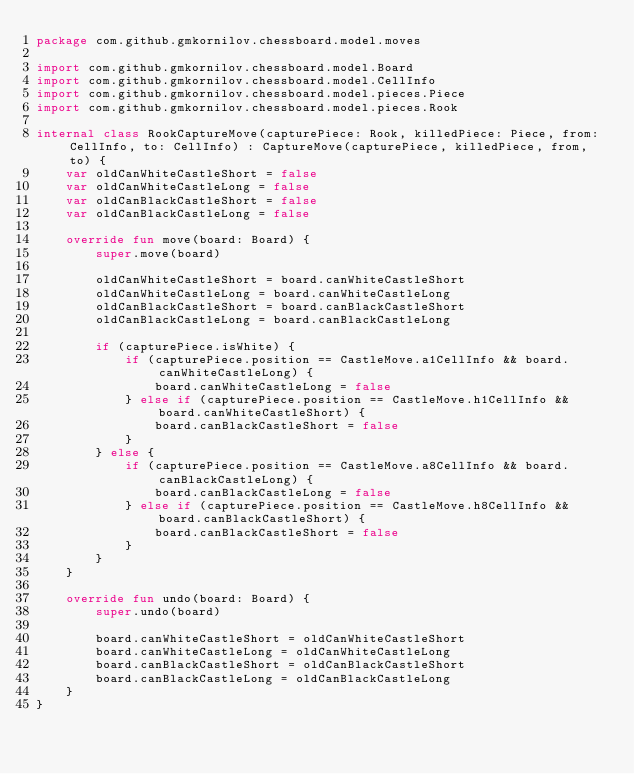Convert code to text. <code><loc_0><loc_0><loc_500><loc_500><_Kotlin_>package com.github.gmkornilov.chessboard.model.moves

import com.github.gmkornilov.chessboard.model.Board
import com.github.gmkornilov.chessboard.model.CellInfo
import com.github.gmkornilov.chessboard.model.pieces.Piece
import com.github.gmkornilov.chessboard.model.pieces.Rook

internal class RookCaptureMove(capturePiece: Rook, killedPiece: Piece, from: CellInfo, to: CellInfo) : CaptureMove(capturePiece, killedPiece, from, to) {
    var oldCanWhiteCastleShort = false
    var oldCanWhiteCastleLong = false
    var oldCanBlackCastleShort = false
    var oldCanBlackCastleLong = false

    override fun move(board: Board) {
        super.move(board)

        oldCanWhiteCastleShort = board.canWhiteCastleShort
        oldCanWhiteCastleLong = board.canWhiteCastleLong
        oldCanBlackCastleShort = board.canBlackCastleShort
        oldCanBlackCastleLong = board.canBlackCastleLong

        if (capturePiece.isWhite) {
            if (capturePiece.position == CastleMove.a1CellInfo && board.canWhiteCastleLong) {
                board.canWhiteCastleLong = false
            } else if (capturePiece.position == CastleMove.h1CellInfo && board.canWhiteCastleShort) {
                board.canBlackCastleShort = false
            }
        } else {
            if (capturePiece.position == CastleMove.a8CellInfo && board.canBlackCastleLong) {
                board.canBlackCastleLong = false
            } else if (capturePiece.position == CastleMove.h8CellInfo && board.canBlackCastleShort) {
                board.canBlackCastleShort = false
            }
        }
    }

    override fun undo(board: Board) {
        super.undo(board)

        board.canWhiteCastleShort = oldCanWhiteCastleShort
        board.canWhiteCastleLong = oldCanWhiteCastleLong
        board.canBlackCastleShort = oldCanBlackCastleShort
        board.canBlackCastleLong = oldCanBlackCastleLong
    }
}</code> 